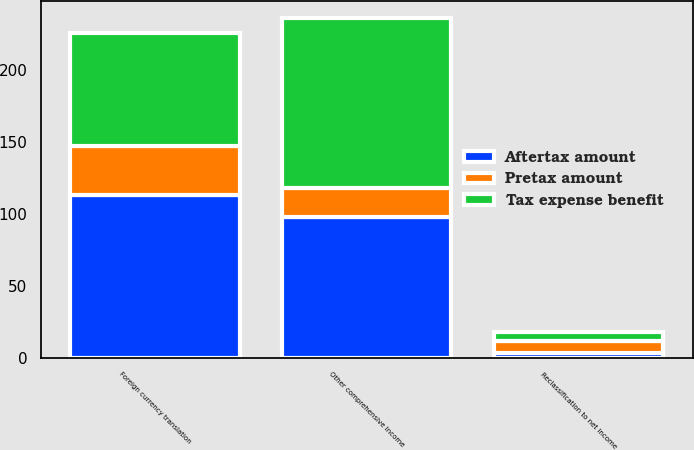Convert chart. <chart><loc_0><loc_0><loc_500><loc_500><stacked_bar_chart><ecel><fcel>Foreign currency translation<fcel>Reclassification to net income<fcel>Other comprehensive income<nl><fcel>Pretax amount<fcel>34<fcel>9<fcel>20<nl><fcel>Aftertax amount<fcel>113<fcel>3<fcel>98<nl><fcel>Tax expense benefit<fcel>79<fcel>6<fcel>118<nl></chart> 